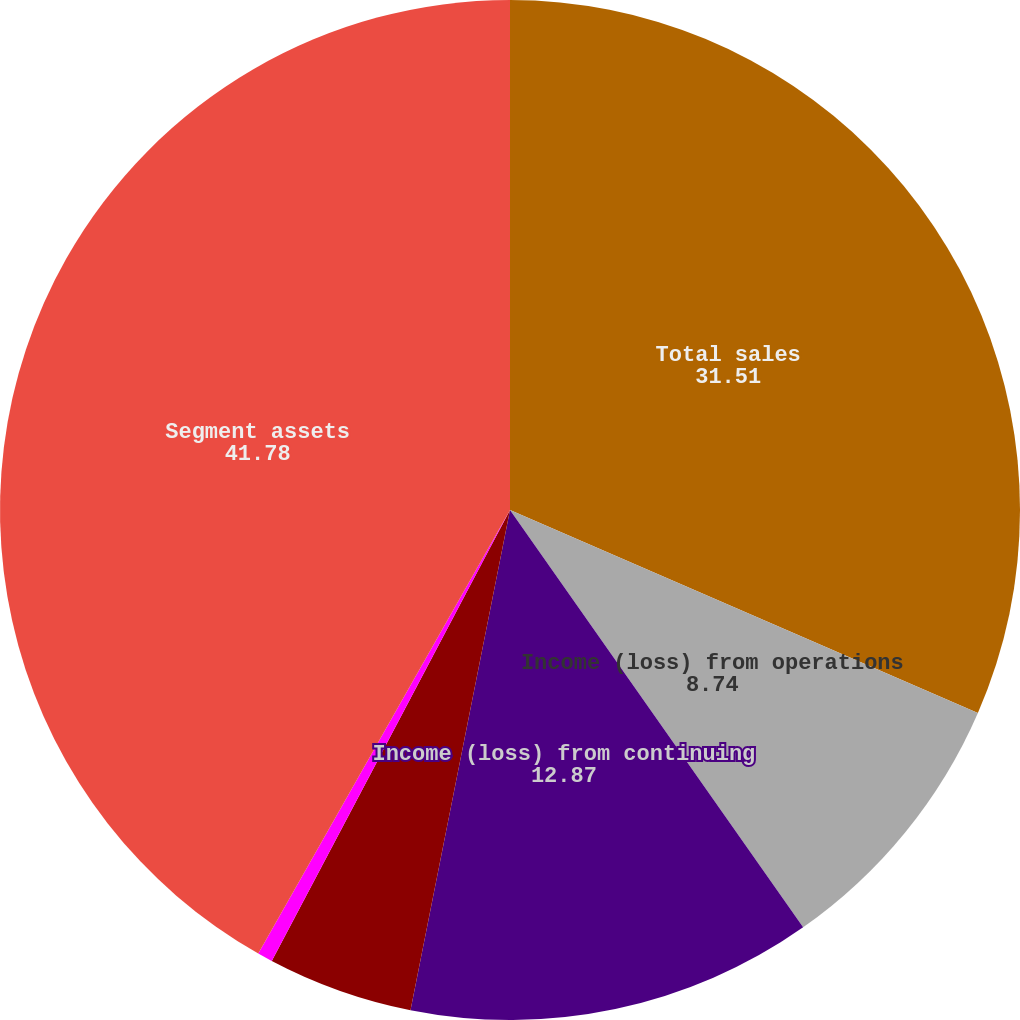Convert chart to OTSL. <chart><loc_0><loc_0><loc_500><loc_500><pie_chart><fcel>Total sales<fcel>Income (loss) from operations<fcel>Income (loss) from continuing<fcel>Depreciation and amortization<fcel>Capital expenditures<fcel>Segment assets<nl><fcel>31.51%<fcel>8.74%<fcel>12.87%<fcel>4.61%<fcel>0.48%<fcel>41.78%<nl></chart> 